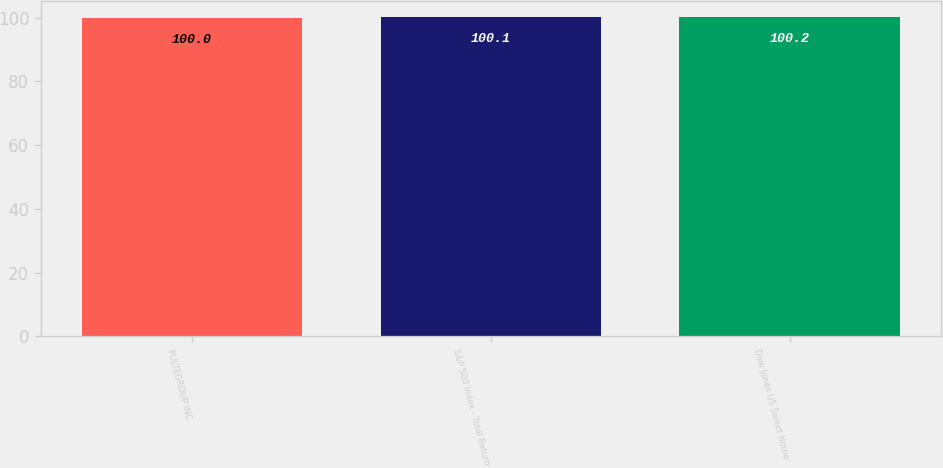Convert chart. <chart><loc_0><loc_0><loc_500><loc_500><bar_chart><fcel>PULTEGROUP INC<fcel>S&P 500 Index - Total Return<fcel>Dow Jones US Select Home<nl><fcel>100<fcel>100.1<fcel>100.2<nl></chart> 